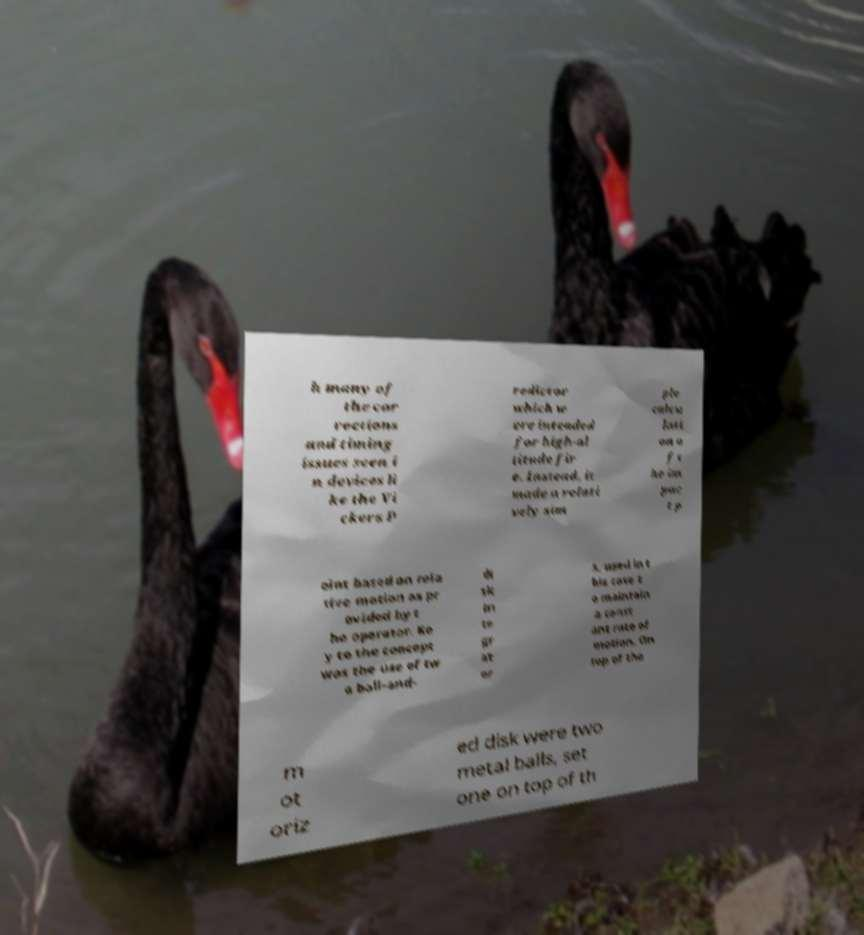Can you accurately transcribe the text from the provided image for me? h many of the cor rections and timing issues seen i n devices li ke the Vi ckers P redictor which w ere intended for high-al titude fir e. Instead, it made a relati vely sim ple calcu lati on o f t he im pac t p oint based on rela tive motion as pr ovided by t he operator. Ke y to the concept was the use of tw o ball-and- di sk in te gr at or s, used in t his case t o maintain a const ant rate of motion. On top of the m ot oriz ed disk were two metal balls, set one on top of th 